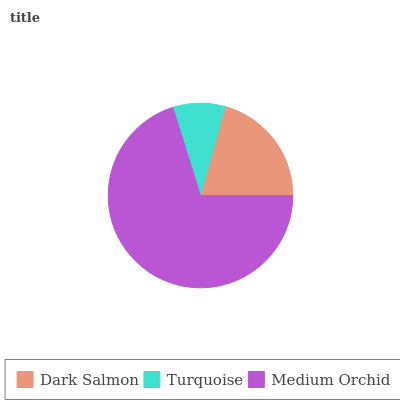Is Turquoise the minimum?
Answer yes or no. Yes. Is Medium Orchid the maximum?
Answer yes or no. Yes. Is Medium Orchid the minimum?
Answer yes or no. No. Is Turquoise the maximum?
Answer yes or no. No. Is Medium Orchid greater than Turquoise?
Answer yes or no. Yes. Is Turquoise less than Medium Orchid?
Answer yes or no. Yes. Is Turquoise greater than Medium Orchid?
Answer yes or no. No. Is Medium Orchid less than Turquoise?
Answer yes or no. No. Is Dark Salmon the high median?
Answer yes or no. Yes. Is Dark Salmon the low median?
Answer yes or no. Yes. Is Medium Orchid the high median?
Answer yes or no. No. Is Medium Orchid the low median?
Answer yes or no. No. 